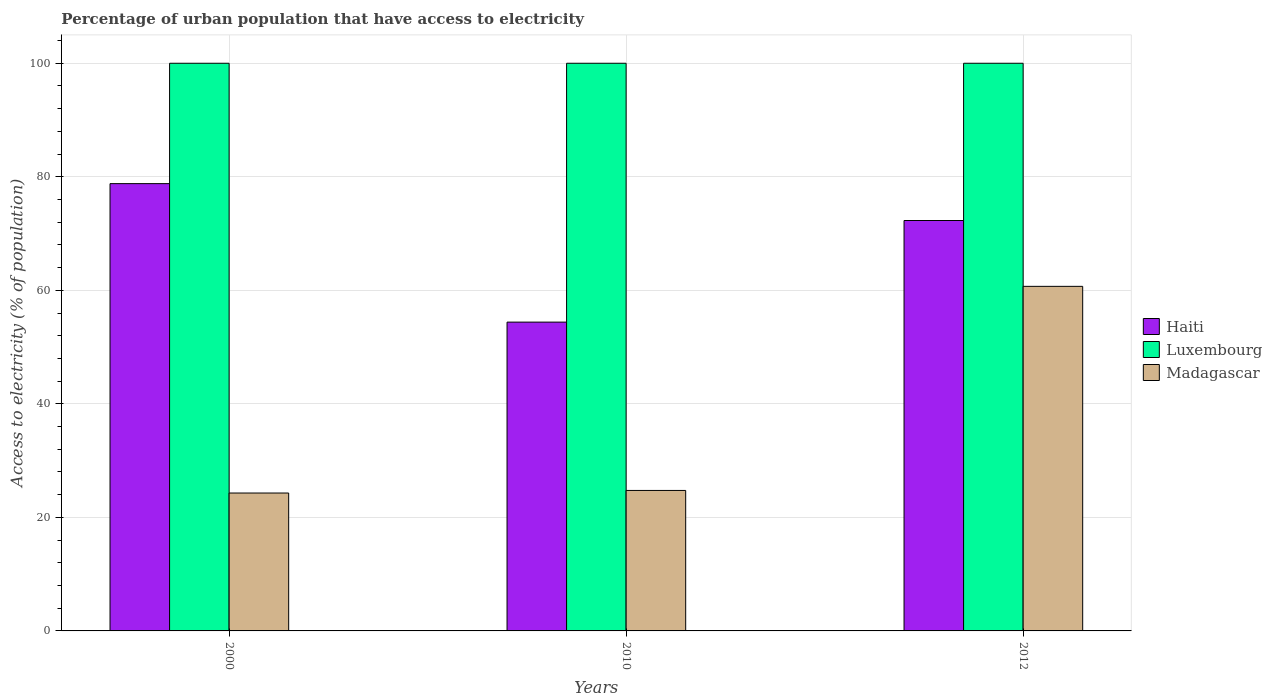How many different coloured bars are there?
Provide a succinct answer. 3. Are the number of bars on each tick of the X-axis equal?
Make the answer very short. Yes. How many bars are there on the 2nd tick from the left?
Ensure brevity in your answer.  3. How many bars are there on the 3rd tick from the right?
Make the answer very short. 3. What is the percentage of urban population that have access to electricity in Madagascar in 2010?
Give a very brief answer. 24.75. Across all years, what is the maximum percentage of urban population that have access to electricity in Luxembourg?
Give a very brief answer. 100. Across all years, what is the minimum percentage of urban population that have access to electricity in Haiti?
Give a very brief answer. 54.4. In which year was the percentage of urban population that have access to electricity in Madagascar maximum?
Provide a succinct answer. 2012. What is the total percentage of urban population that have access to electricity in Luxembourg in the graph?
Make the answer very short. 300. What is the difference between the percentage of urban population that have access to electricity in Haiti in 2010 and the percentage of urban population that have access to electricity in Madagascar in 2012?
Make the answer very short. -6.3. What is the average percentage of urban population that have access to electricity in Madagascar per year?
Ensure brevity in your answer.  36.58. In the year 2012, what is the difference between the percentage of urban population that have access to electricity in Luxembourg and percentage of urban population that have access to electricity in Haiti?
Ensure brevity in your answer.  27.7. What is the ratio of the percentage of urban population that have access to electricity in Madagascar in 2000 to that in 2012?
Provide a short and direct response. 0.4. Is the percentage of urban population that have access to electricity in Haiti in 2000 less than that in 2010?
Provide a short and direct response. No. What is the difference between the highest and the second highest percentage of urban population that have access to electricity in Madagascar?
Make the answer very short. 35.95. Is the sum of the percentage of urban population that have access to electricity in Luxembourg in 2000 and 2010 greater than the maximum percentage of urban population that have access to electricity in Madagascar across all years?
Provide a short and direct response. Yes. What does the 1st bar from the left in 2012 represents?
Your answer should be compact. Haiti. What does the 2nd bar from the right in 2010 represents?
Provide a short and direct response. Luxembourg. Is it the case that in every year, the sum of the percentage of urban population that have access to electricity in Madagascar and percentage of urban population that have access to electricity in Luxembourg is greater than the percentage of urban population that have access to electricity in Haiti?
Make the answer very short. Yes. How many bars are there?
Your answer should be very brief. 9. What is the difference between two consecutive major ticks on the Y-axis?
Give a very brief answer. 20. Are the values on the major ticks of Y-axis written in scientific E-notation?
Keep it short and to the point. No. Does the graph contain any zero values?
Your answer should be very brief. No. Where does the legend appear in the graph?
Keep it short and to the point. Center right. What is the title of the graph?
Ensure brevity in your answer.  Percentage of urban population that have access to electricity. What is the label or title of the X-axis?
Your response must be concise. Years. What is the label or title of the Y-axis?
Offer a very short reply. Access to electricity (% of population). What is the Access to electricity (% of population) in Haiti in 2000?
Offer a very short reply. 78.8. What is the Access to electricity (% of population) in Madagascar in 2000?
Make the answer very short. 24.29. What is the Access to electricity (% of population) in Haiti in 2010?
Make the answer very short. 54.4. What is the Access to electricity (% of population) of Luxembourg in 2010?
Offer a terse response. 100. What is the Access to electricity (% of population) of Madagascar in 2010?
Keep it short and to the point. 24.75. What is the Access to electricity (% of population) of Haiti in 2012?
Give a very brief answer. 72.3. What is the Access to electricity (% of population) in Luxembourg in 2012?
Provide a short and direct response. 100. What is the Access to electricity (% of population) in Madagascar in 2012?
Ensure brevity in your answer.  60.7. Across all years, what is the maximum Access to electricity (% of population) in Haiti?
Your answer should be compact. 78.8. Across all years, what is the maximum Access to electricity (% of population) of Madagascar?
Provide a short and direct response. 60.7. Across all years, what is the minimum Access to electricity (% of population) of Haiti?
Keep it short and to the point. 54.4. Across all years, what is the minimum Access to electricity (% of population) of Luxembourg?
Provide a short and direct response. 100. Across all years, what is the minimum Access to electricity (% of population) of Madagascar?
Offer a very short reply. 24.29. What is the total Access to electricity (% of population) of Haiti in the graph?
Make the answer very short. 205.5. What is the total Access to electricity (% of population) in Luxembourg in the graph?
Your answer should be compact. 300. What is the total Access to electricity (% of population) in Madagascar in the graph?
Your answer should be compact. 109.74. What is the difference between the Access to electricity (% of population) of Haiti in 2000 and that in 2010?
Keep it short and to the point. 24.39. What is the difference between the Access to electricity (% of population) in Luxembourg in 2000 and that in 2010?
Give a very brief answer. 0. What is the difference between the Access to electricity (% of population) of Madagascar in 2000 and that in 2010?
Your response must be concise. -0.45. What is the difference between the Access to electricity (% of population) in Haiti in 2000 and that in 2012?
Offer a very short reply. 6.5. What is the difference between the Access to electricity (% of population) of Madagascar in 2000 and that in 2012?
Make the answer very short. -36.41. What is the difference between the Access to electricity (% of population) of Haiti in 2010 and that in 2012?
Ensure brevity in your answer.  -17.9. What is the difference between the Access to electricity (% of population) in Madagascar in 2010 and that in 2012?
Keep it short and to the point. -35.95. What is the difference between the Access to electricity (% of population) of Haiti in 2000 and the Access to electricity (% of population) of Luxembourg in 2010?
Keep it short and to the point. -21.2. What is the difference between the Access to electricity (% of population) in Haiti in 2000 and the Access to electricity (% of population) in Madagascar in 2010?
Make the answer very short. 54.05. What is the difference between the Access to electricity (% of population) of Luxembourg in 2000 and the Access to electricity (% of population) of Madagascar in 2010?
Ensure brevity in your answer.  75.25. What is the difference between the Access to electricity (% of population) of Haiti in 2000 and the Access to electricity (% of population) of Luxembourg in 2012?
Give a very brief answer. -21.2. What is the difference between the Access to electricity (% of population) in Haiti in 2000 and the Access to electricity (% of population) in Madagascar in 2012?
Provide a succinct answer. 18.1. What is the difference between the Access to electricity (% of population) in Luxembourg in 2000 and the Access to electricity (% of population) in Madagascar in 2012?
Provide a short and direct response. 39.3. What is the difference between the Access to electricity (% of population) in Haiti in 2010 and the Access to electricity (% of population) in Luxembourg in 2012?
Offer a very short reply. -45.6. What is the difference between the Access to electricity (% of population) in Haiti in 2010 and the Access to electricity (% of population) in Madagascar in 2012?
Keep it short and to the point. -6.3. What is the difference between the Access to electricity (% of population) in Luxembourg in 2010 and the Access to electricity (% of population) in Madagascar in 2012?
Make the answer very short. 39.3. What is the average Access to electricity (% of population) in Haiti per year?
Provide a succinct answer. 68.5. What is the average Access to electricity (% of population) in Luxembourg per year?
Provide a succinct answer. 100. What is the average Access to electricity (% of population) in Madagascar per year?
Provide a short and direct response. 36.58. In the year 2000, what is the difference between the Access to electricity (% of population) of Haiti and Access to electricity (% of population) of Luxembourg?
Offer a terse response. -21.2. In the year 2000, what is the difference between the Access to electricity (% of population) in Haiti and Access to electricity (% of population) in Madagascar?
Your answer should be very brief. 54.5. In the year 2000, what is the difference between the Access to electricity (% of population) in Luxembourg and Access to electricity (% of population) in Madagascar?
Provide a short and direct response. 75.71. In the year 2010, what is the difference between the Access to electricity (% of population) of Haiti and Access to electricity (% of population) of Luxembourg?
Give a very brief answer. -45.6. In the year 2010, what is the difference between the Access to electricity (% of population) of Haiti and Access to electricity (% of population) of Madagascar?
Provide a succinct answer. 29.65. In the year 2010, what is the difference between the Access to electricity (% of population) of Luxembourg and Access to electricity (% of population) of Madagascar?
Your answer should be very brief. 75.25. In the year 2012, what is the difference between the Access to electricity (% of population) in Haiti and Access to electricity (% of population) in Luxembourg?
Offer a terse response. -27.7. In the year 2012, what is the difference between the Access to electricity (% of population) in Haiti and Access to electricity (% of population) in Madagascar?
Make the answer very short. 11.6. In the year 2012, what is the difference between the Access to electricity (% of population) of Luxembourg and Access to electricity (% of population) of Madagascar?
Your answer should be very brief. 39.3. What is the ratio of the Access to electricity (% of population) of Haiti in 2000 to that in 2010?
Give a very brief answer. 1.45. What is the ratio of the Access to electricity (% of population) in Luxembourg in 2000 to that in 2010?
Your response must be concise. 1. What is the ratio of the Access to electricity (% of population) of Madagascar in 2000 to that in 2010?
Give a very brief answer. 0.98. What is the ratio of the Access to electricity (% of population) in Haiti in 2000 to that in 2012?
Offer a very short reply. 1.09. What is the ratio of the Access to electricity (% of population) in Madagascar in 2000 to that in 2012?
Provide a succinct answer. 0.4. What is the ratio of the Access to electricity (% of population) of Haiti in 2010 to that in 2012?
Ensure brevity in your answer.  0.75. What is the ratio of the Access to electricity (% of population) of Madagascar in 2010 to that in 2012?
Offer a terse response. 0.41. What is the difference between the highest and the second highest Access to electricity (% of population) in Haiti?
Provide a succinct answer. 6.5. What is the difference between the highest and the second highest Access to electricity (% of population) of Madagascar?
Ensure brevity in your answer.  35.95. What is the difference between the highest and the lowest Access to electricity (% of population) in Haiti?
Your answer should be compact. 24.39. What is the difference between the highest and the lowest Access to electricity (% of population) in Madagascar?
Make the answer very short. 36.41. 